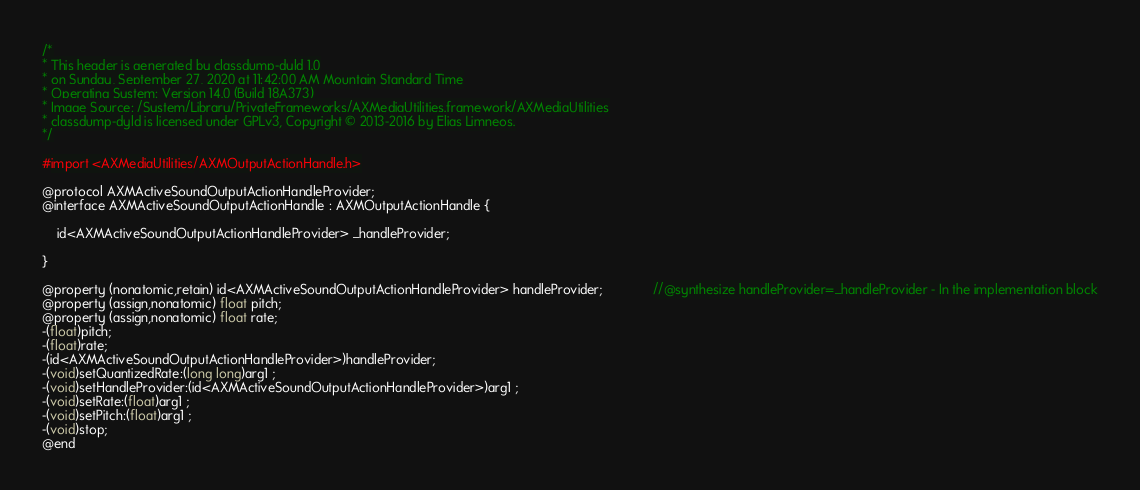<code> <loc_0><loc_0><loc_500><loc_500><_C_>/*
* This header is generated by classdump-dyld 1.0
* on Sunday, September 27, 2020 at 11:42:00 AM Mountain Standard Time
* Operating System: Version 14.0 (Build 18A373)
* Image Source: /System/Library/PrivateFrameworks/AXMediaUtilities.framework/AXMediaUtilities
* classdump-dyld is licensed under GPLv3, Copyright © 2013-2016 by Elias Limneos.
*/

#import <AXMediaUtilities/AXMOutputActionHandle.h>

@protocol AXMActiveSoundOutputActionHandleProvider;
@interface AXMActiveSoundOutputActionHandle : AXMOutputActionHandle {

	id<AXMActiveSoundOutputActionHandleProvider> _handleProvider;

}

@property (nonatomic,retain) id<AXMActiveSoundOutputActionHandleProvider> handleProvider;              //@synthesize handleProvider=_handleProvider - In the implementation block
@property (assign,nonatomic) float pitch; 
@property (assign,nonatomic) float rate; 
-(float)pitch;
-(float)rate;
-(id<AXMActiveSoundOutputActionHandleProvider>)handleProvider;
-(void)setQuantizedRate:(long long)arg1 ;
-(void)setHandleProvider:(id<AXMActiveSoundOutputActionHandleProvider>)arg1 ;
-(void)setRate:(float)arg1 ;
-(void)setPitch:(float)arg1 ;
-(void)stop;
@end

</code> 